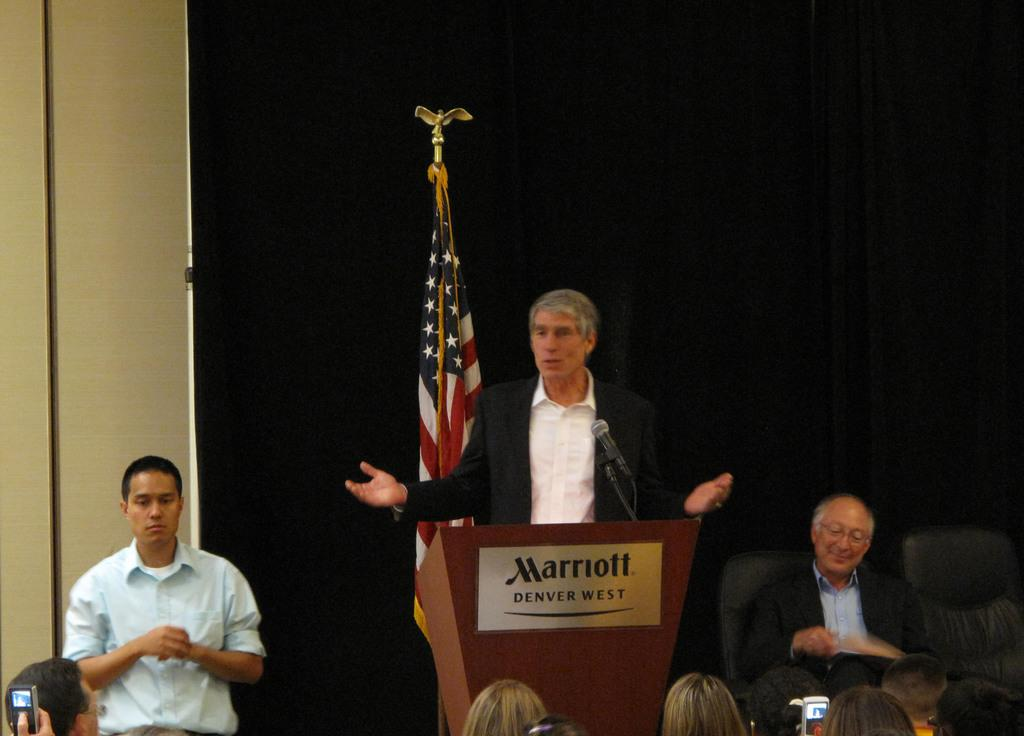What objects can be seen in the image related to communication or presentations? In the image, there is a flag, a podium, a microphone (mic), and a group of people. What type of furniture is present in the image? Chairs can be seen in the image. What is the color of the curtain in the image? The curtain in the image is black. Can you describe the background of the image? There is a wall in the image. How many men are standing in the group? Two men are standing in the group. What type of whistle can be heard in the image? There is no whistle present or audible in the image. What is the man sitting in the group trying to cover with a stop sign? There is no stop sign or covering action depicted in the image. 